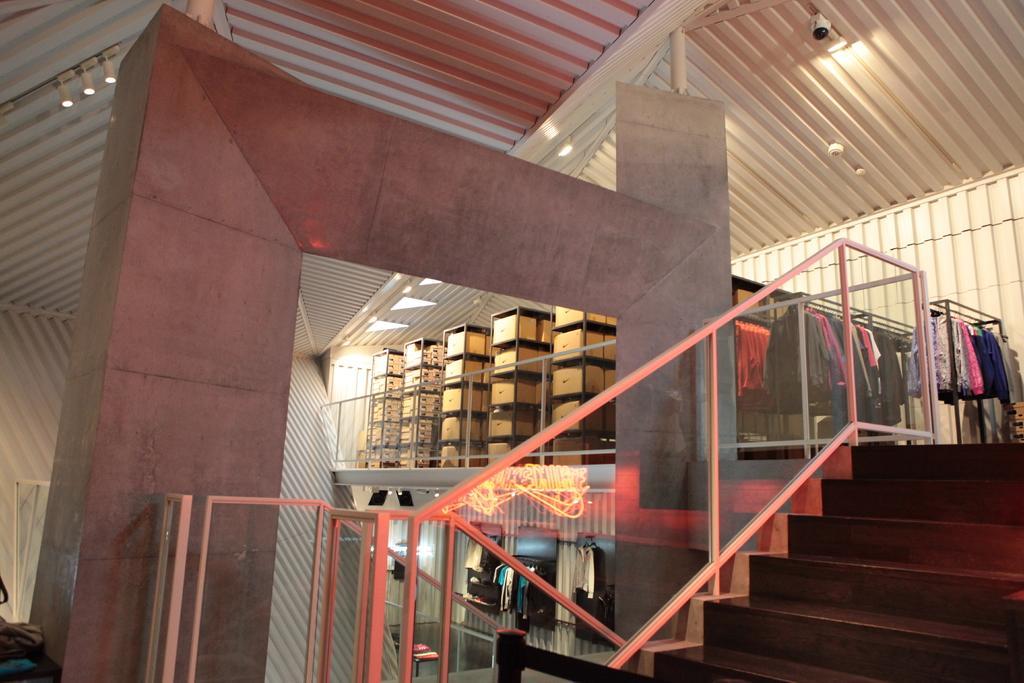How would you summarize this image in a sentence or two? This picture is inside view of a room. In the middle of the image we can see boxes, clothes, stand are present. On the right side of the image stairs are there. At the top of the image roof, cc camera, lights are present. At the bottom of the image floor is there. 